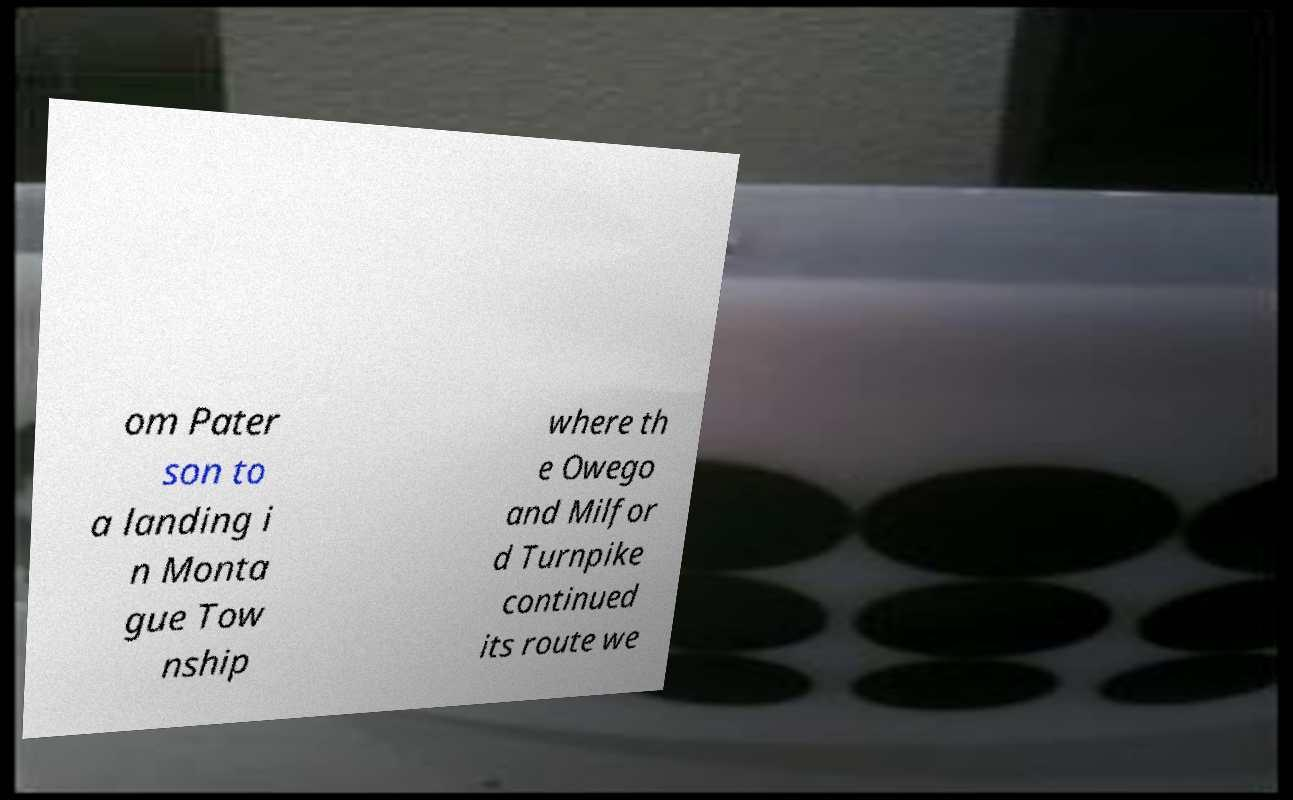Please identify and transcribe the text found in this image. om Pater son to a landing i n Monta gue Tow nship where th e Owego and Milfor d Turnpike continued its route we 